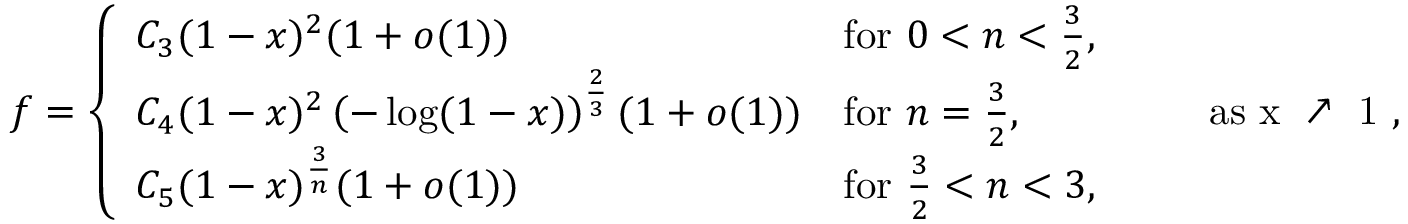<formula> <loc_0><loc_0><loc_500><loc_500>f = \left \{ \begin{array} { l l } { C _ { 3 } ( 1 - x ) ^ { 2 } ( 1 + o ( 1 ) ) } & { f o r 0 < n < \frac { 3 } { 2 } , } \\ { C _ { 4 } ( 1 - x ) ^ { 2 } \left ( - \log ( 1 - x ) \right ) ^ { \frac { 2 } { 3 } } ( 1 + o ( 1 ) ) } & { f o r n = \frac { 3 } { 2 } , } \\ { C _ { 5 } ( 1 - x ) ^ { \frac { 3 } { n } } ( 1 + o ( 1 ) ) } & { f o r \frac { 3 } { 2 } < n < 3 , } \end{array} \quad a s x \nearrow 1 ,</formula> 